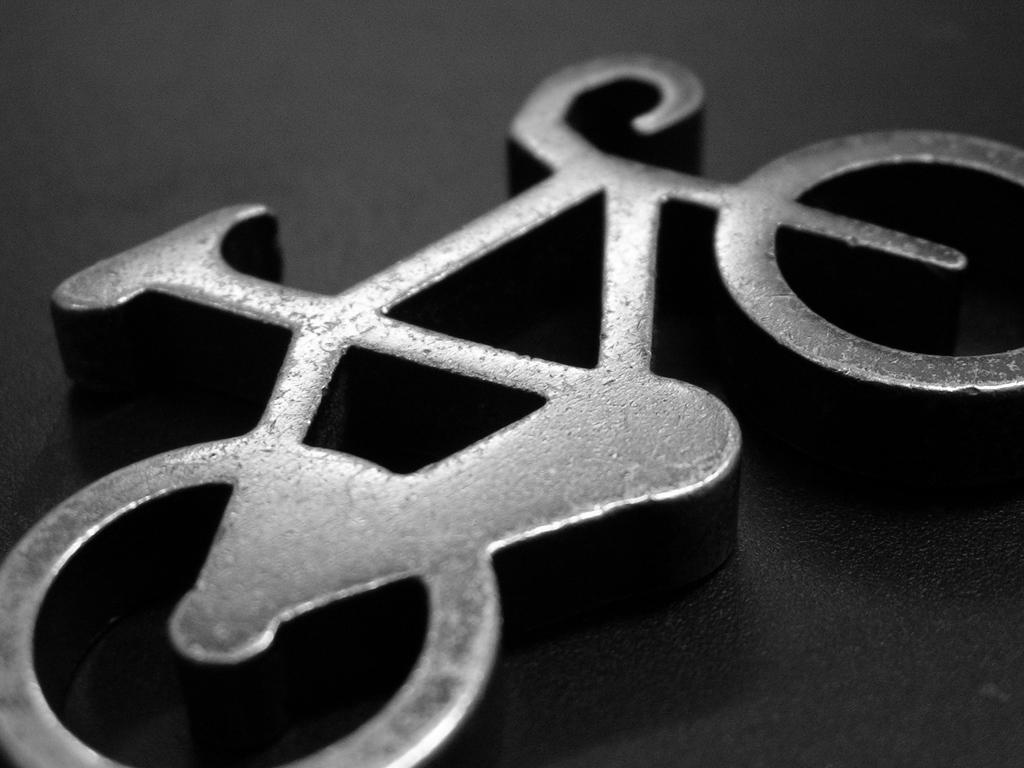Could you give a brief overview of what you see in this image? In this image we can see a metallic cycle. 